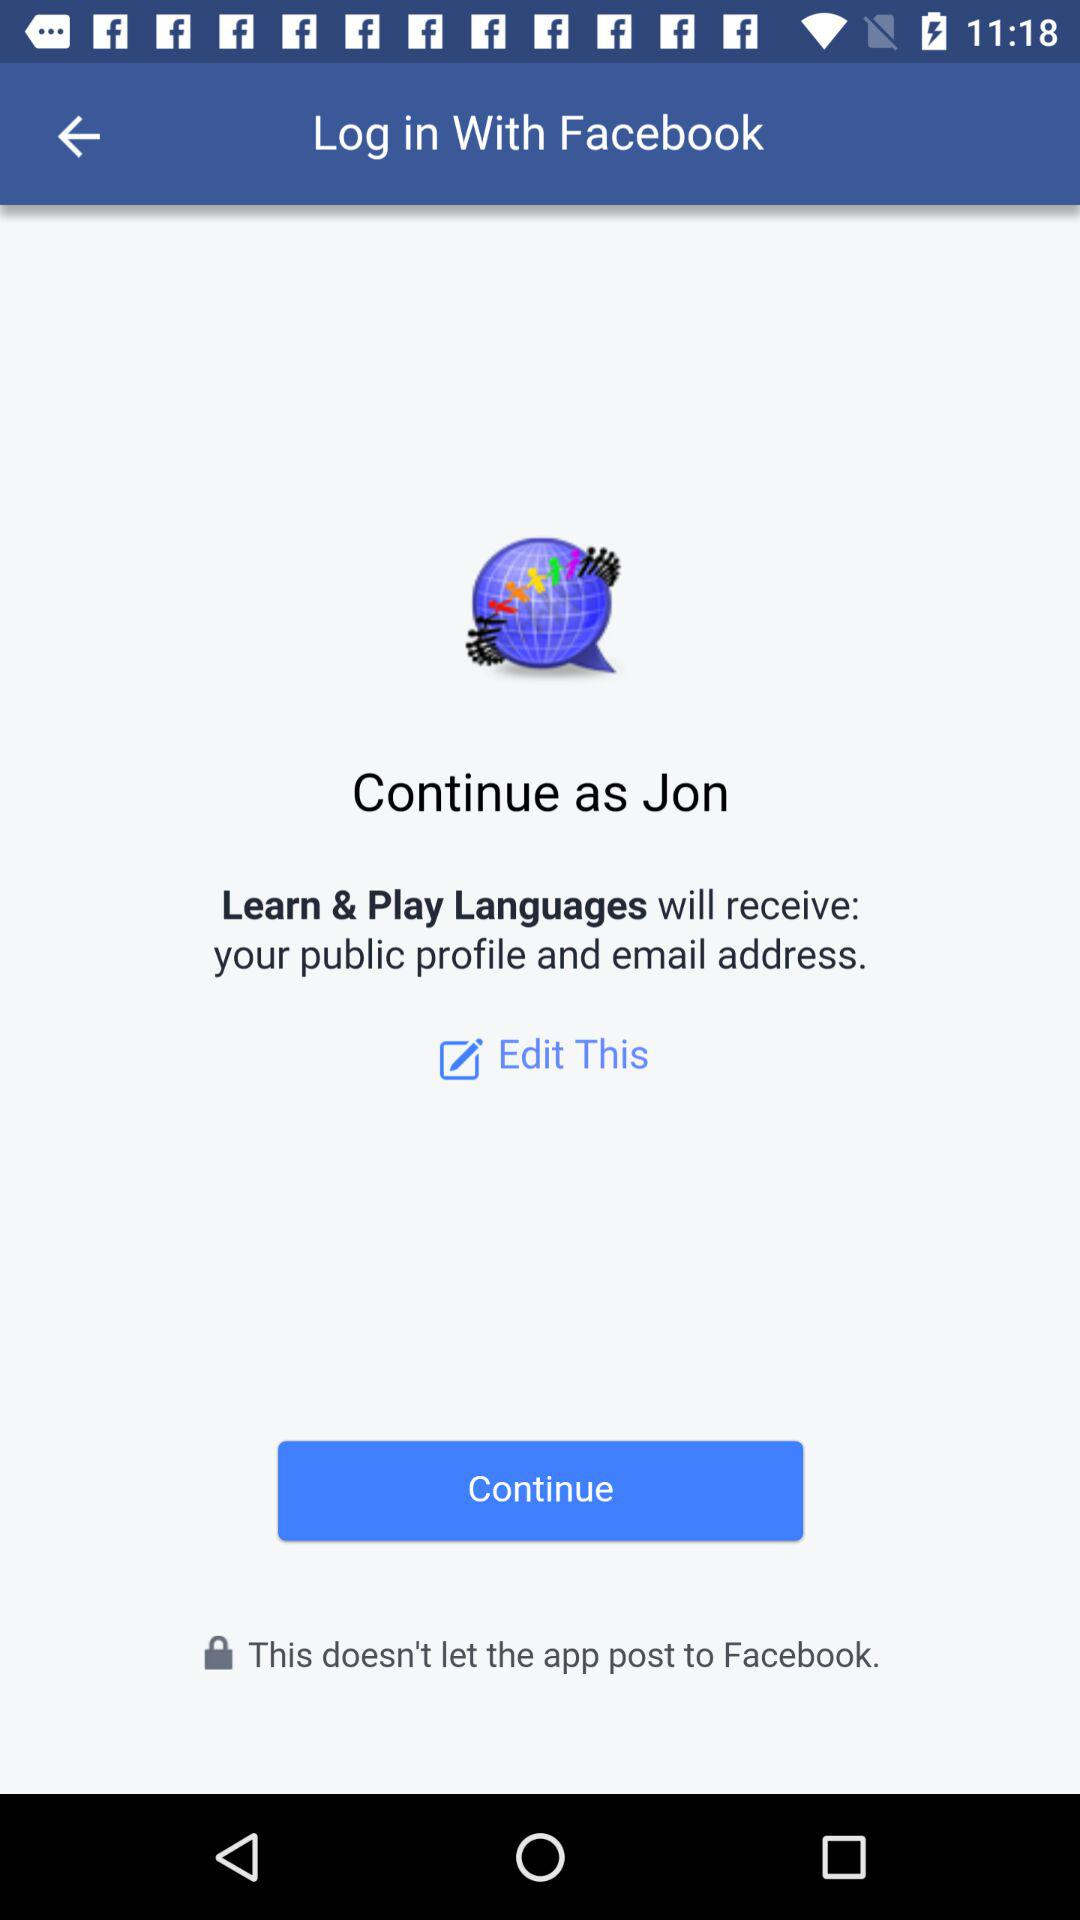What is the user name to continue the profile? The user name to continue the profile is Jon. 